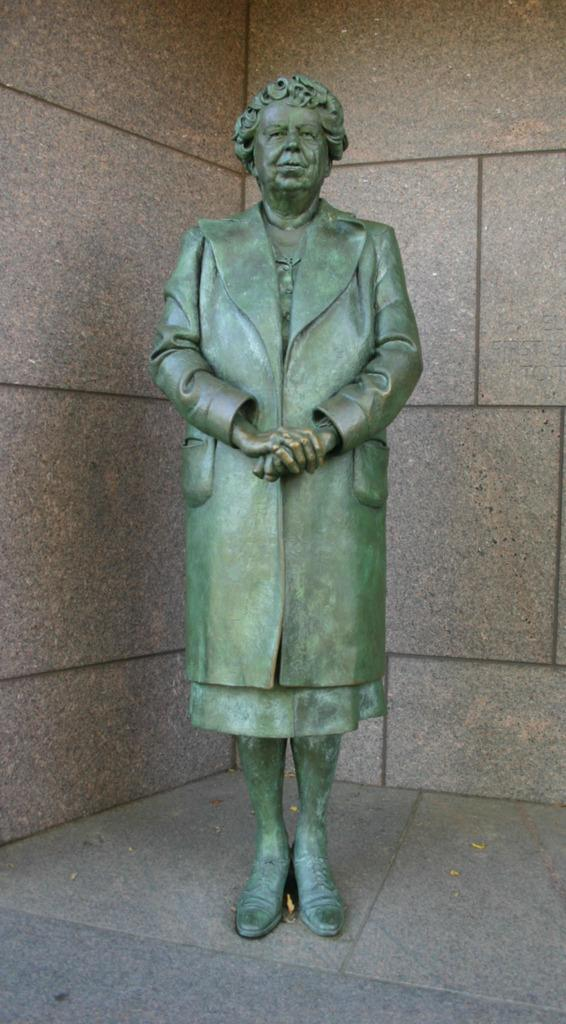What is the main subject in the center of the image? There is a statue in the center of the image. What can be seen in the background of the image? There is a wall in the background of the image. What type of pail is hanging on the statue in the image? There is no pail present in the image. What does the statue represent in terms of hope? The image does not provide any information about the statue's representation of hope. 